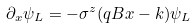Convert formula to latex. <formula><loc_0><loc_0><loc_500><loc_500>\partial _ { x } \psi _ { L } = - \sigma ^ { z } ( q B x - k ) \psi _ { L }</formula> 